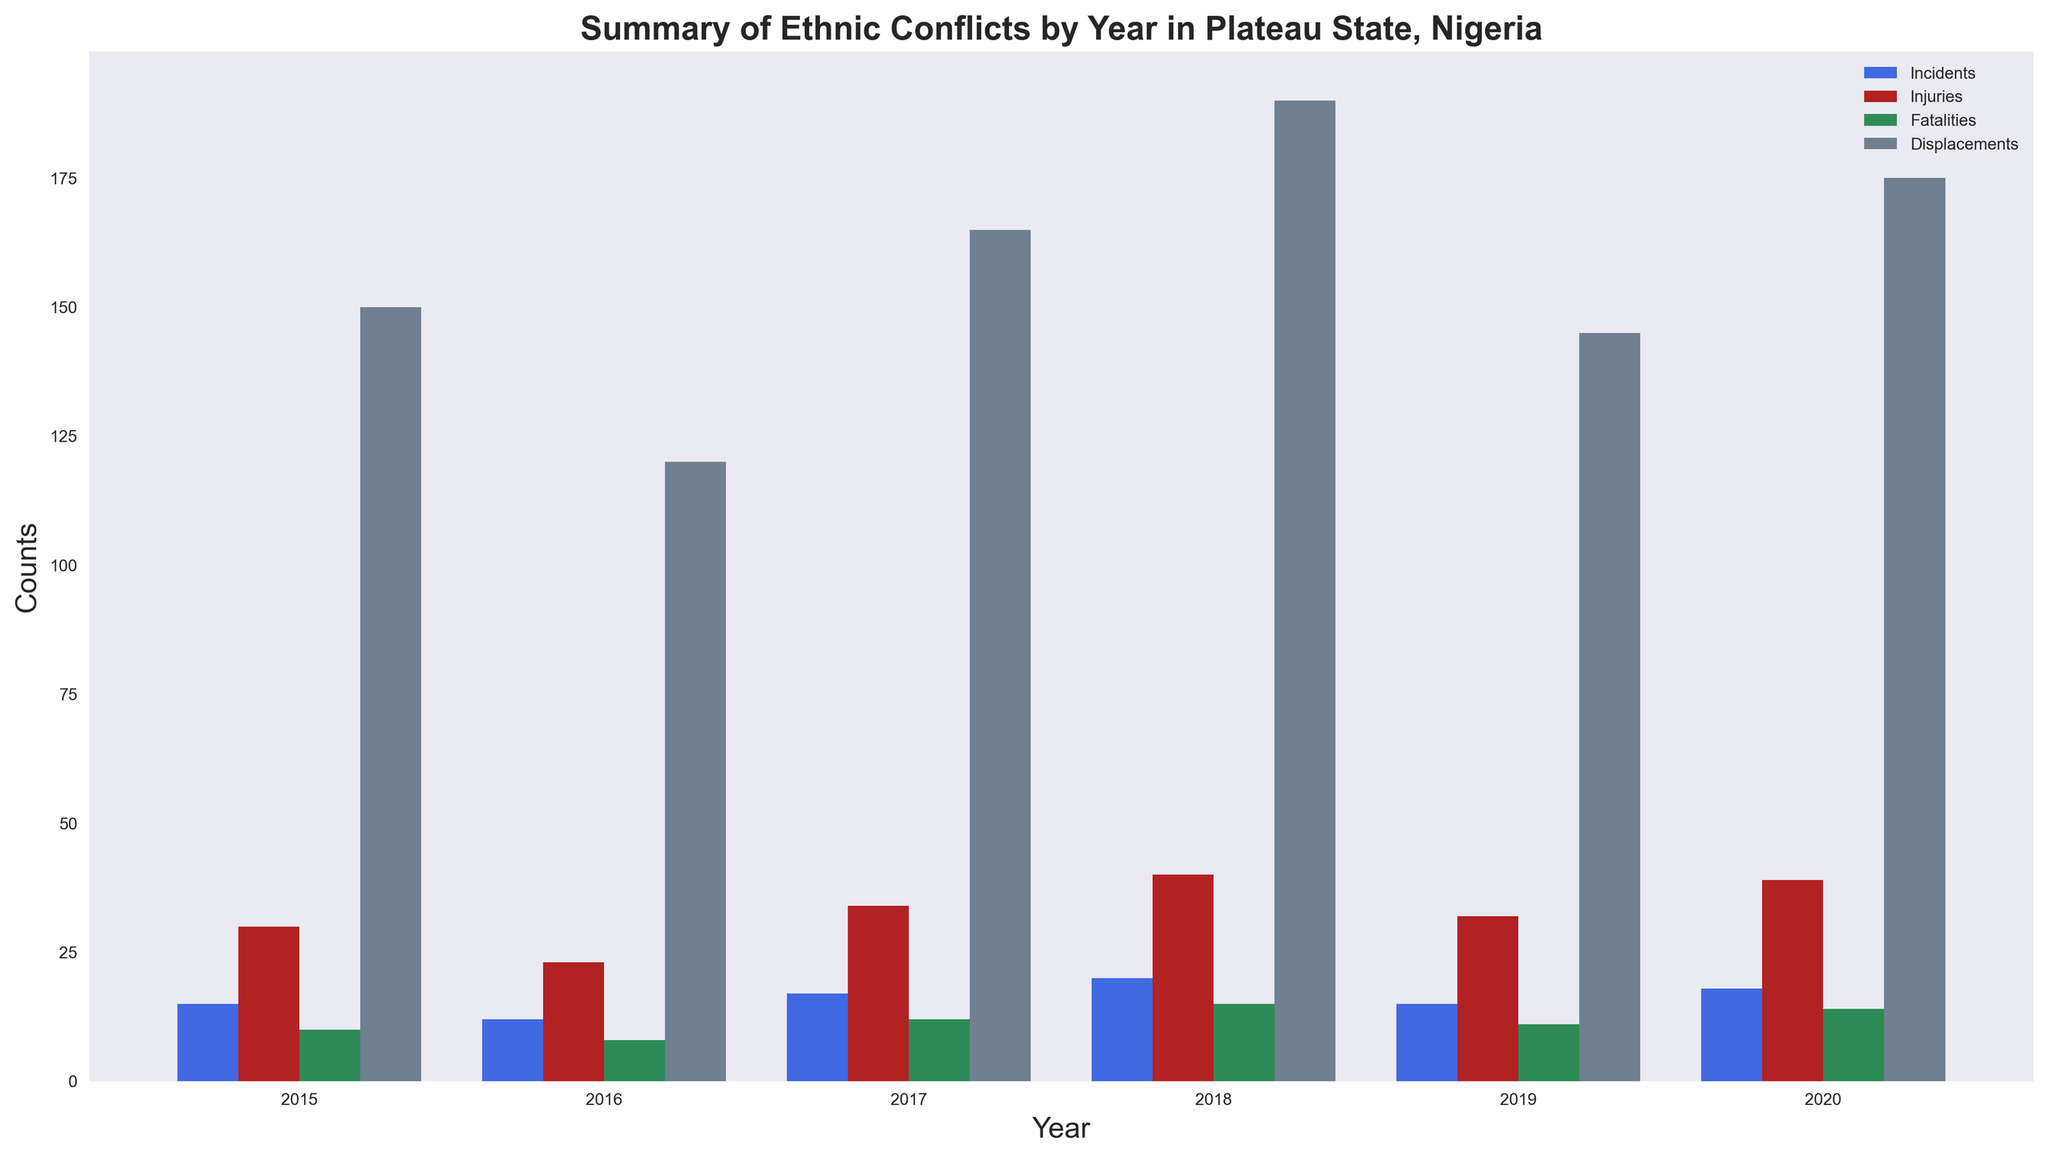What year had the highest number of incidents, and how many incidents occurred that year? First, look at the height of the bars representing incidents for each year. The blue bar (representing incidents) in 2018 is the tallest, indicating the highest number of incidents. Verify by checking the exact counts shown in the plot.
Answer: 2018, 20 incidents Which year experienced the most displacements and how many displacements were there? Find the tallest gray bar for displacements. The gray bar for 2018 is the tallest compared to other years. Read the exact count from the plot.
Answer: 2018, 190 displacements What is the average number of fatalities per year from 2015 to 2020? Sum the fatality counts for all years: 3 + 2 + 5 + 3 + 1 + 4 + 4 + 2 + 6 + 5 + 3 + 7 + 4 + 2 + 5 + 5 + 3 + 6 = 68. Then, divide by the number of years: 68 / 6 ≈ 11.3.
Answer: 11.33 Which year had the least number of injuries, and what was the number? Compare the heights of the red bars showing injuries for each year. The red bar for 2016 is the shortest. Verify with the count displayed on the plot.
Answer: 2016, 23 injuries Did incidents, injuries, fatalities, or displacements increase or decrease from 2016 to 2017? Compare the heights of all bars from 2016 to 2017. Incidents: increased (12 to 17), Injuries: increased (23 to 34), Fatalities: increased (8 to 12), Displacements: increased (120 to 165).
Answer: All increased Compare the number of displacements in 2019 to those in 2015. Which year had more displacements and by how much? Find the gray bar heights for 2019 and 2015. 2019 has a bar of height 145, and 2015 has a bar of height 150. Subtract the two numbers. 150 - 145 = 5.
Answer: 2015, by 5 What is the total number of incidents in 2017? Sum the incidents for all communities in 2017: 6 (Barkin Ladi) + 3 (Bokkos) + 8 (Jos North) = 17.
Answer: 17 Which year had the second highest number of fatalities, and how many were there? Identify the heights of the green bars for fatalities. The tallest bar is for 2018, the second tallest is for 2020. Verify the counts: 2020 has 14 fatalities.
Answer: 2020, 14 fatalities Did the number of incidents, injuries, fatalities, and displacements in 2020 show an increasing or decreasing trend compared to 2019? Compare the heights of the relevant bars for 2019 to 2020. The counts for 2019 are Incidents: 15, Injuries: 32, Fatalities: 11, Displacements: 145. For 2020, they are Incidents: 18, Injuries: 39, Fatalities: 14, Displacements: 175. All these metrics increased.
Answer: Increasing trend 